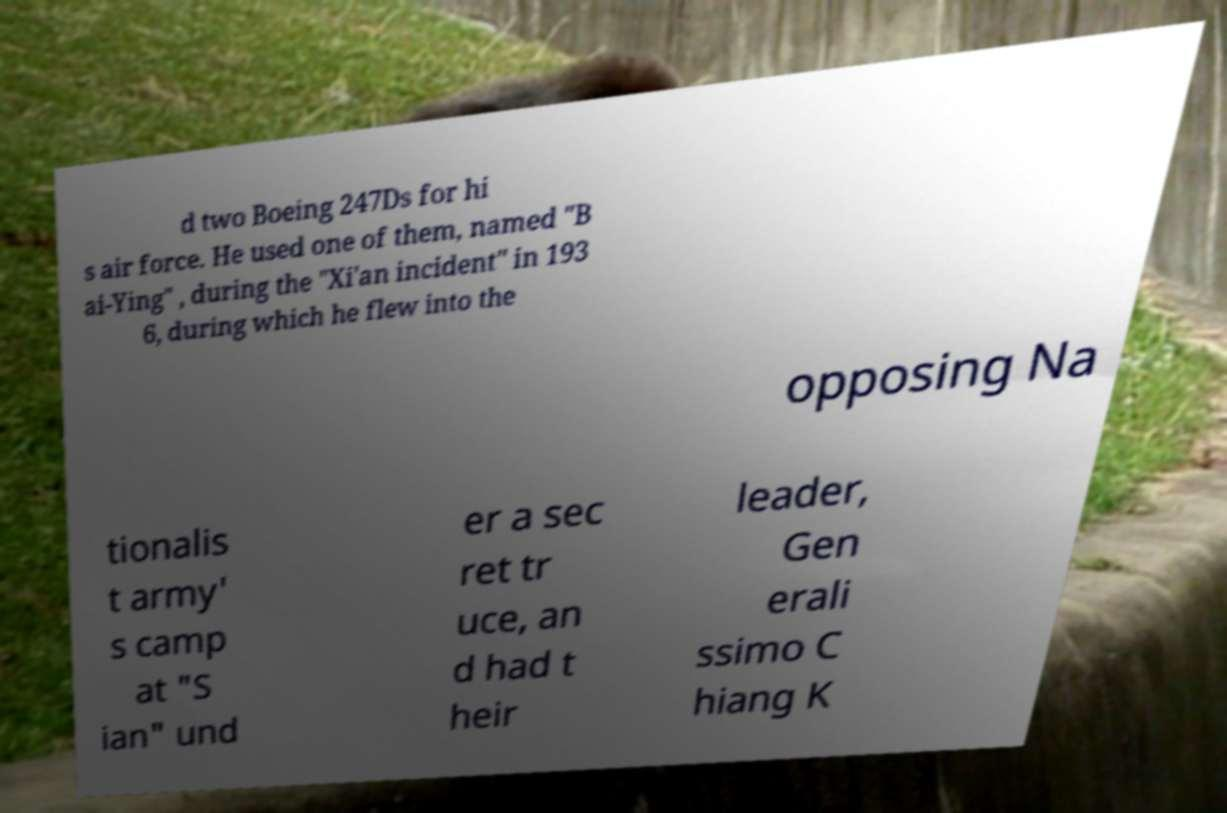Please identify and transcribe the text found in this image. d two Boeing 247Ds for hi s air force. He used one of them, named "B ai-Ying" , during the "Xi'an incident" in 193 6, during which he flew into the opposing Na tionalis t army' s camp at "S ian" und er a sec ret tr uce, an d had t heir leader, Gen erali ssimo C hiang K 